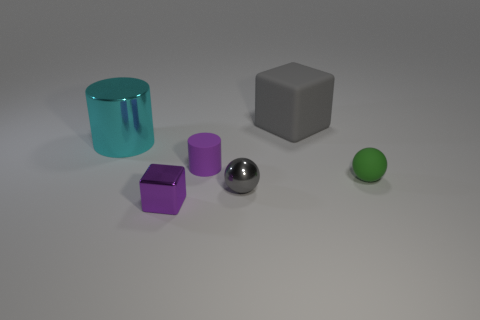Add 2 blue things. How many objects exist? 8 Add 1 purple cylinders. How many purple cylinders exist? 2 Subtract 1 cyan cylinders. How many objects are left? 5 Subtract all spheres. How many objects are left? 4 Subtract all large red metallic cubes. Subtract all small purple rubber cylinders. How many objects are left? 5 Add 5 tiny green matte balls. How many tiny green matte balls are left? 6 